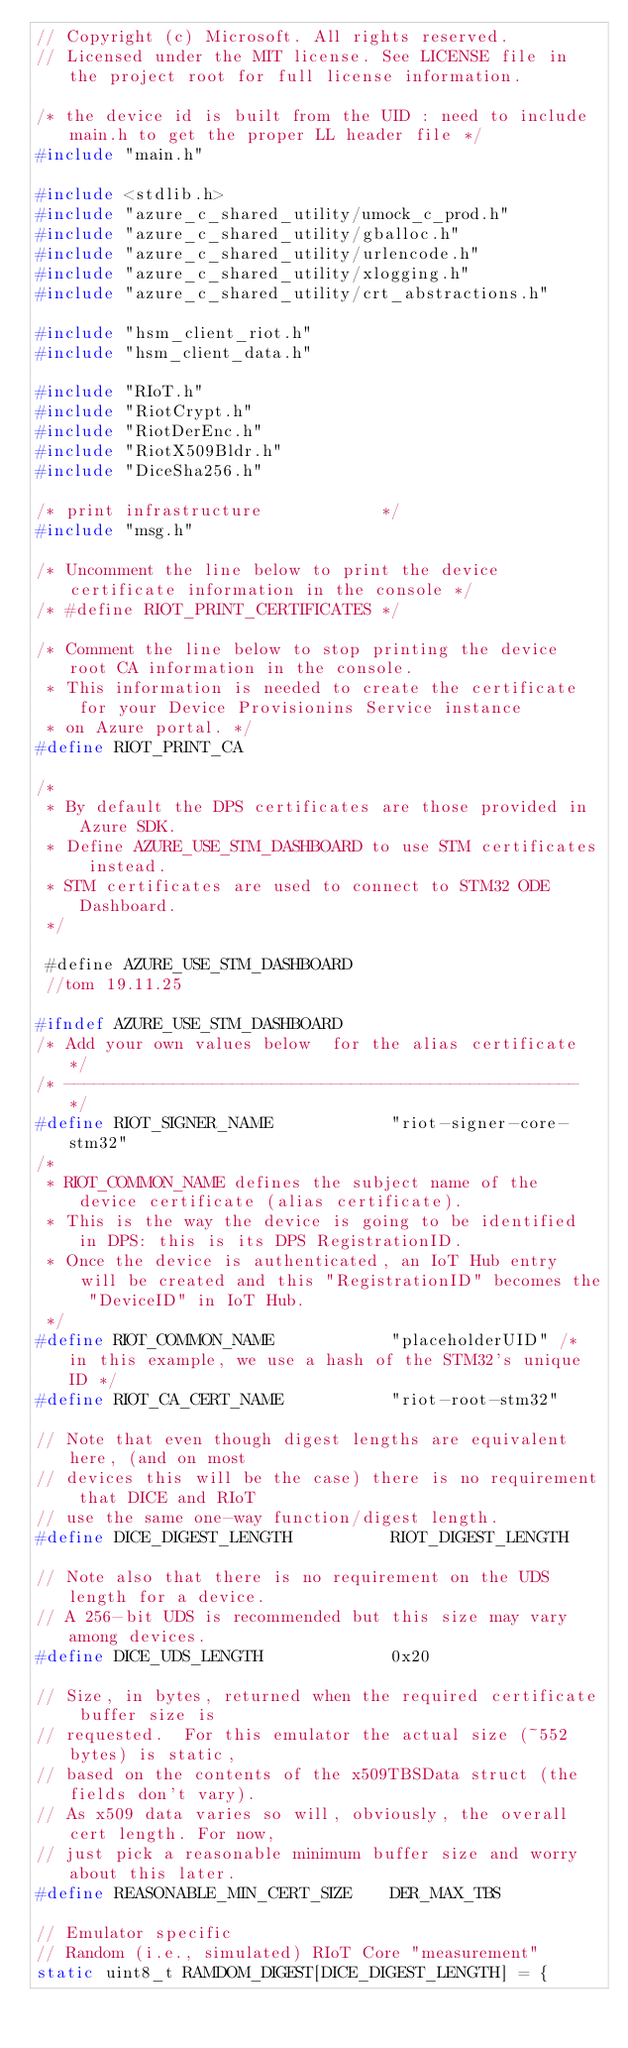<code> <loc_0><loc_0><loc_500><loc_500><_C_>// Copyright (c) Microsoft. All rights reserved.
// Licensed under the MIT license. See LICENSE file in the project root for full license information.

/* the device id is built from the UID : need to include main.h to get the proper LL header file */
#include "main.h"

#include <stdlib.h>
#include "azure_c_shared_utility/umock_c_prod.h"
#include "azure_c_shared_utility/gballoc.h"
#include "azure_c_shared_utility/urlencode.h"
#include "azure_c_shared_utility/xlogging.h"
#include "azure_c_shared_utility/crt_abstractions.h"

#include "hsm_client_riot.h"
#include "hsm_client_data.h"

#include "RIoT.h"
#include "RiotCrypt.h"
#include "RiotDerEnc.h"
#include "RiotX509Bldr.h"
#include "DiceSha256.h"

/* print infrastructure            */
#include "msg.h"

/* Uncomment the line below to print the device certificate information in the console */
/* #define RIOT_PRINT_CERTIFICATES */

/* Comment the line below to stop printing the device root CA information in the console.
 * This information is needed to create the certificate for your Device Provisionins Service instance
 * on Azure portal. */
#define RIOT_PRINT_CA

/* 
 * By default the DPS certificates are those provided in Azure SDK.
 * Define AZURE_USE_STM_DASHBOARD to use STM certificates instead.
 * STM certificates are used to connect to STM32 ODE Dashboard.
 */
 
 #define AZURE_USE_STM_DASHBOARD
 //tom 19.11.25
 
#ifndef AZURE_USE_STM_DASHBOARD
/* Add your own values below  for the alias certificate */
/* ---------------------------------------------------- */
#define RIOT_SIGNER_NAME            "riot-signer-core-stm32"
/*
 * RIOT_COMMON_NAME defines the subject name of the device certificate (alias certificate).
 * This is the way the device is going to be identified in DPS: this is its DPS RegistrationID.
 * Once the device is authenticated, an IoT Hub entry will be created and this "RegistrationID" becomes the "DeviceID" in IoT Hub.
 */
#define RIOT_COMMON_NAME            "placeholderUID" /* in this example, we use a hash of the STM32's unique ID */
#define RIOT_CA_CERT_NAME           "riot-root-stm32"

// Note that even though digest lengths are equivalent here, (and on most
// devices this will be the case) there is no requirement that DICE and RIoT
// use the same one-way function/digest length.
#define DICE_DIGEST_LENGTH          RIOT_DIGEST_LENGTH

// Note also that there is no requirement on the UDS length for a device.
// A 256-bit UDS is recommended but this size may vary among devices.
#define DICE_UDS_LENGTH             0x20

// Size, in bytes, returned when the required certificate buffer size is
// requested.  For this emulator the actual size (~552 bytes) is static,
// based on the contents of the x509TBSData struct (the fields don't vary).
// As x509 data varies so will, obviously, the overall cert length. For now,
// just pick a reasonable minimum buffer size and worry about this later.
#define REASONABLE_MIN_CERT_SIZE    DER_MAX_TBS

// Emulator specific
// Random (i.e., simulated) RIoT Core "measurement"
static uint8_t RAMDOM_DIGEST[DICE_DIGEST_LENGTH] = {</code> 